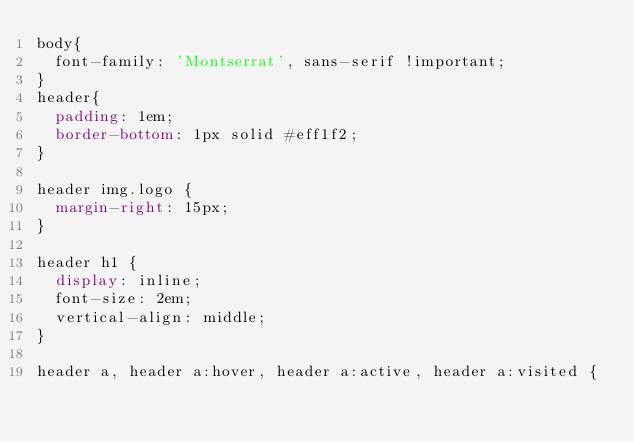Convert code to text. <code><loc_0><loc_0><loc_500><loc_500><_CSS_>body{
	font-family: 'Montserrat', sans-serif !important;
}
header{
	padding: 1em;
	border-bottom: 1px solid #eff1f2;
}

header img.logo {
	margin-right: 15px;
}

header h1 {
	display: inline;
	font-size: 2em;
	vertical-align: middle;
}

header a, header a:hover, header a:active, header a:visited {</code> 